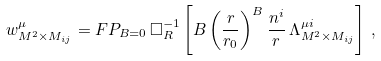Convert formula to latex. <formula><loc_0><loc_0><loc_500><loc_500>w ^ { \mu } _ { M ^ { 2 } \times M _ { i j } } = F P _ { B = 0 } \, \Box ^ { - 1 } _ { R } \left [ B \left ( \frac { r } { r _ { 0 } } \right ) ^ { B } \frac { n ^ { i } } { r } \, \Lambda ^ { \mu i } _ { M ^ { 2 } \times M _ { i j } } \right ] \, ,</formula> 